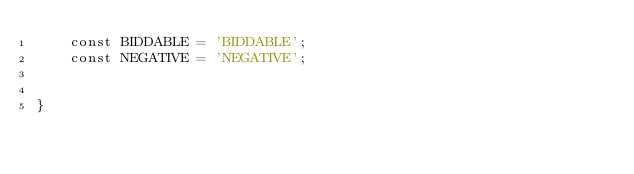<code> <loc_0><loc_0><loc_500><loc_500><_PHP_>    const BIDDABLE = 'BIDDABLE';
    const NEGATIVE = 'NEGATIVE';


}
</code> 